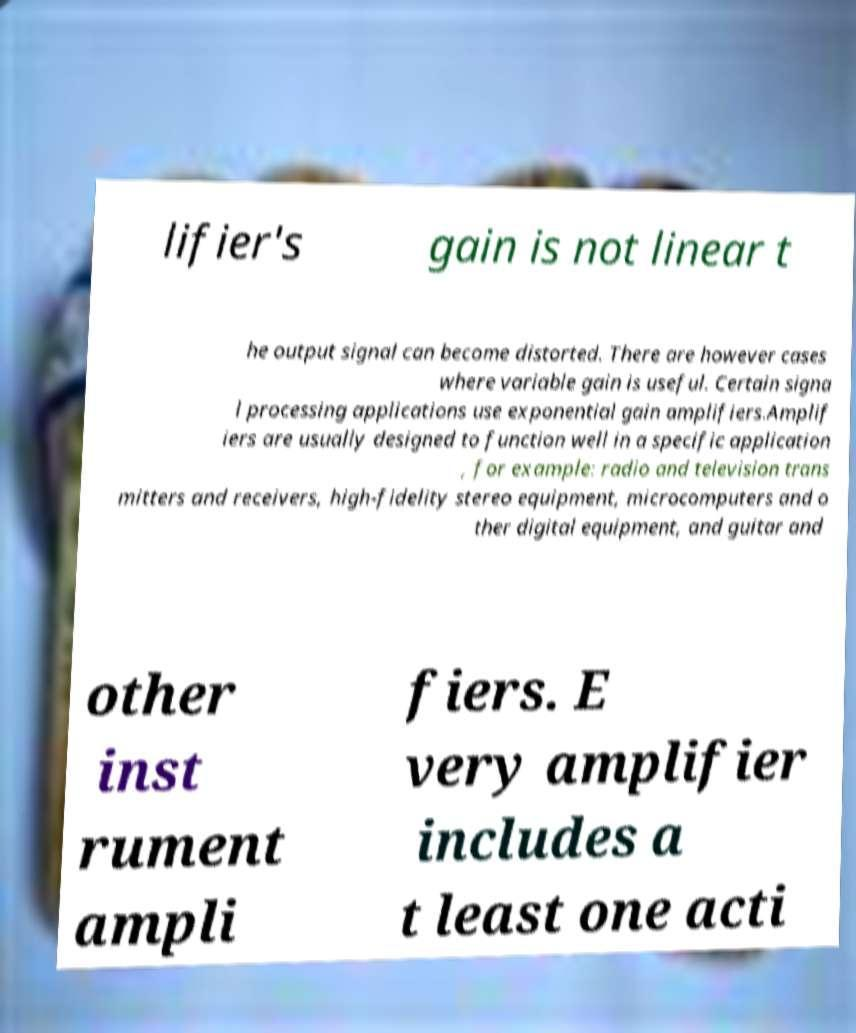Can you read and provide the text displayed in the image?This photo seems to have some interesting text. Can you extract and type it out for me? lifier's gain is not linear t he output signal can become distorted. There are however cases where variable gain is useful. Certain signa l processing applications use exponential gain amplifiers.Amplif iers are usually designed to function well in a specific application , for example: radio and television trans mitters and receivers, high-fidelity stereo equipment, microcomputers and o ther digital equipment, and guitar and other inst rument ampli fiers. E very amplifier includes a t least one acti 